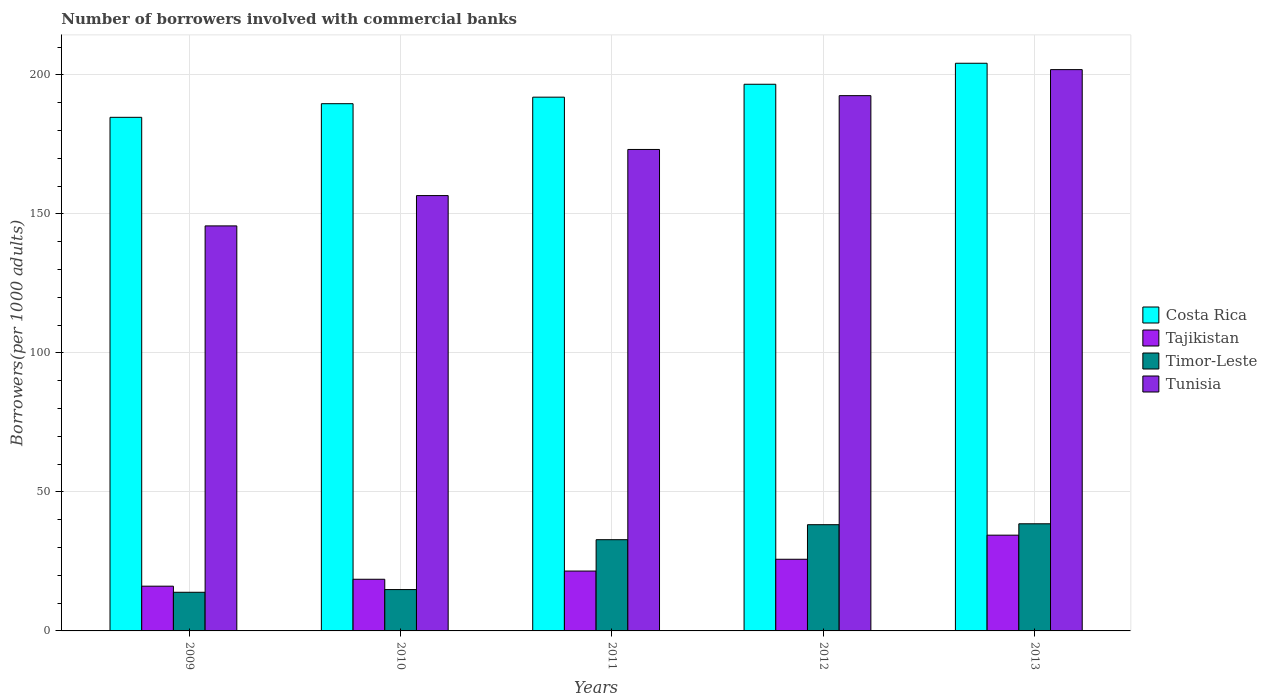How many different coloured bars are there?
Provide a succinct answer. 4. How many groups of bars are there?
Provide a succinct answer. 5. Are the number of bars per tick equal to the number of legend labels?
Give a very brief answer. Yes. How many bars are there on the 3rd tick from the left?
Give a very brief answer. 4. What is the label of the 4th group of bars from the left?
Ensure brevity in your answer.  2012. What is the number of borrowers involved with commercial banks in Tajikistan in 2010?
Ensure brevity in your answer.  18.58. Across all years, what is the maximum number of borrowers involved with commercial banks in Tajikistan?
Your response must be concise. 34.44. Across all years, what is the minimum number of borrowers involved with commercial banks in Tajikistan?
Provide a succinct answer. 16.09. In which year was the number of borrowers involved with commercial banks in Costa Rica maximum?
Offer a terse response. 2013. What is the total number of borrowers involved with commercial banks in Timor-Leste in the graph?
Keep it short and to the point. 138.33. What is the difference between the number of borrowers involved with commercial banks in Costa Rica in 2010 and that in 2011?
Keep it short and to the point. -2.35. What is the difference between the number of borrowers involved with commercial banks in Timor-Leste in 2011 and the number of borrowers involved with commercial banks in Tajikistan in 2012?
Your response must be concise. 7.04. What is the average number of borrowers involved with commercial banks in Timor-Leste per year?
Give a very brief answer. 27.67. In the year 2011, what is the difference between the number of borrowers involved with commercial banks in Costa Rica and number of borrowers involved with commercial banks in Timor-Leste?
Give a very brief answer. 159.17. What is the ratio of the number of borrowers involved with commercial banks in Costa Rica in 2010 to that in 2011?
Your answer should be compact. 0.99. What is the difference between the highest and the second highest number of borrowers involved with commercial banks in Tunisia?
Provide a short and direct response. 9.37. What is the difference between the highest and the lowest number of borrowers involved with commercial banks in Timor-Leste?
Provide a succinct answer. 24.63. In how many years, is the number of borrowers involved with commercial banks in Costa Rica greater than the average number of borrowers involved with commercial banks in Costa Rica taken over all years?
Provide a succinct answer. 2. What does the 4th bar from the left in 2012 represents?
Provide a succinct answer. Tunisia. What does the 3rd bar from the right in 2009 represents?
Ensure brevity in your answer.  Tajikistan. Is it the case that in every year, the sum of the number of borrowers involved with commercial banks in Tajikistan and number of borrowers involved with commercial banks in Costa Rica is greater than the number of borrowers involved with commercial banks in Tunisia?
Give a very brief answer. Yes. How many bars are there?
Make the answer very short. 20. How many years are there in the graph?
Provide a short and direct response. 5. Are the values on the major ticks of Y-axis written in scientific E-notation?
Your response must be concise. No. Does the graph contain any zero values?
Provide a succinct answer. No. How many legend labels are there?
Provide a succinct answer. 4. How are the legend labels stacked?
Provide a succinct answer. Vertical. What is the title of the graph?
Your answer should be very brief. Number of borrowers involved with commercial banks. Does "Tonga" appear as one of the legend labels in the graph?
Give a very brief answer. No. What is the label or title of the X-axis?
Ensure brevity in your answer.  Years. What is the label or title of the Y-axis?
Your response must be concise. Borrowers(per 1000 adults). What is the Borrowers(per 1000 adults) of Costa Rica in 2009?
Your answer should be very brief. 184.73. What is the Borrowers(per 1000 adults) in Tajikistan in 2009?
Provide a succinct answer. 16.09. What is the Borrowers(per 1000 adults) of Timor-Leste in 2009?
Provide a short and direct response. 13.9. What is the Borrowers(per 1000 adults) of Tunisia in 2009?
Offer a very short reply. 145.68. What is the Borrowers(per 1000 adults) in Costa Rica in 2010?
Make the answer very short. 189.63. What is the Borrowers(per 1000 adults) of Tajikistan in 2010?
Your answer should be compact. 18.58. What is the Borrowers(per 1000 adults) in Timor-Leste in 2010?
Give a very brief answer. 14.87. What is the Borrowers(per 1000 adults) in Tunisia in 2010?
Your response must be concise. 156.58. What is the Borrowers(per 1000 adults) in Costa Rica in 2011?
Your response must be concise. 191.98. What is the Borrowers(per 1000 adults) of Tajikistan in 2011?
Your answer should be compact. 21.53. What is the Borrowers(per 1000 adults) in Timor-Leste in 2011?
Offer a very short reply. 32.81. What is the Borrowers(per 1000 adults) in Tunisia in 2011?
Offer a very short reply. 173.17. What is the Borrowers(per 1000 adults) in Costa Rica in 2012?
Provide a short and direct response. 196.62. What is the Borrowers(per 1000 adults) in Tajikistan in 2012?
Provide a short and direct response. 25.77. What is the Borrowers(per 1000 adults) of Timor-Leste in 2012?
Offer a very short reply. 38.21. What is the Borrowers(per 1000 adults) in Tunisia in 2012?
Provide a short and direct response. 192.52. What is the Borrowers(per 1000 adults) of Costa Rica in 2013?
Ensure brevity in your answer.  204.18. What is the Borrowers(per 1000 adults) in Tajikistan in 2013?
Ensure brevity in your answer.  34.44. What is the Borrowers(per 1000 adults) of Timor-Leste in 2013?
Offer a very short reply. 38.53. What is the Borrowers(per 1000 adults) in Tunisia in 2013?
Keep it short and to the point. 201.89. Across all years, what is the maximum Borrowers(per 1000 adults) in Costa Rica?
Make the answer very short. 204.18. Across all years, what is the maximum Borrowers(per 1000 adults) in Tajikistan?
Your answer should be compact. 34.44. Across all years, what is the maximum Borrowers(per 1000 adults) of Timor-Leste?
Your answer should be compact. 38.53. Across all years, what is the maximum Borrowers(per 1000 adults) of Tunisia?
Offer a terse response. 201.89. Across all years, what is the minimum Borrowers(per 1000 adults) of Costa Rica?
Give a very brief answer. 184.73. Across all years, what is the minimum Borrowers(per 1000 adults) in Tajikistan?
Your answer should be very brief. 16.09. Across all years, what is the minimum Borrowers(per 1000 adults) in Timor-Leste?
Make the answer very short. 13.9. Across all years, what is the minimum Borrowers(per 1000 adults) in Tunisia?
Make the answer very short. 145.68. What is the total Borrowers(per 1000 adults) in Costa Rica in the graph?
Keep it short and to the point. 967.14. What is the total Borrowers(per 1000 adults) in Tajikistan in the graph?
Give a very brief answer. 116.41. What is the total Borrowers(per 1000 adults) in Timor-Leste in the graph?
Your response must be concise. 138.33. What is the total Borrowers(per 1000 adults) in Tunisia in the graph?
Make the answer very short. 869.84. What is the difference between the Borrowers(per 1000 adults) of Costa Rica in 2009 and that in 2010?
Your response must be concise. -4.9. What is the difference between the Borrowers(per 1000 adults) in Tajikistan in 2009 and that in 2010?
Provide a short and direct response. -2.49. What is the difference between the Borrowers(per 1000 adults) of Timor-Leste in 2009 and that in 2010?
Provide a succinct answer. -0.97. What is the difference between the Borrowers(per 1000 adults) of Tunisia in 2009 and that in 2010?
Ensure brevity in your answer.  -10.9. What is the difference between the Borrowers(per 1000 adults) in Costa Rica in 2009 and that in 2011?
Provide a short and direct response. -7.25. What is the difference between the Borrowers(per 1000 adults) in Tajikistan in 2009 and that in 2011?
Your answer should be compact. -5.44. What is the difference between the Borrowers(per 1000 adults) in Timor-Leste in 2009 and that in 2011?
Provide a succinct answer. -18.91. What is the difference between the Borrowers(per 1000 adults) in Tunisia in 2009 and that in 2011?
Your response must be concise. -27.5. What is the difference between the Borrowers(per 1000 adults) in Costa Rica in 2009 and that in 2012?
Keep it short and to the point. -11.9. What is the difference between the Borrowers(per 1000 adults) in Tajikistan in 2009 and that in 2012?
Give a very brief answer. -9.68. What is the difference between the Borrowers(per 1000 adults) in Timor-Leste in 2009 and that in 2012?
Give a very brief answer. -24.31. What is the difference between the Borrowers(per 1000 adults) of Tunisia in 2009 and that in 2012?
Give a very brief answer. -46.85. What is the difference between the Borrowers(per 1000 adults) in Costa Rica in 2009 and that in 2013?
Offer a terse response. -19.45. What is the difference between the Borrowers(per 1000 adults) of Tajikistan in 2009 and that in 2013?
Make the answer very short. -18.35. What is the difference between the Borrowers(per 1000 adults) of Timor-Leste in 2009 and that in 2013?
Offer a terse response. -24.63. What is the difference between the Borrowers(per 1000 adults) of Tunisia in 2009 and that in 2013?
Your answer should be very brief. -56.21. What is the difference between the Borrowers(per 1000 adults) in Costa Rica in 2010 and that in 2011?
Ensure brevity in your answer.  -2.35. What is the difference between the Borrowers(per 1000 adults) of Tajikistan in 2010 and that in 2011?
Give a very brief answer. -2.95. What is the difference between the Borrowers(per 1000 adults) in Timor-Leste in 2010 and that in 2011?
Give a very brief answer. -17.94. What is the difference between the Borrowers(per 1000 adults) of Tunisia in 2010 and that in 2011?
Offer a terse response. -16.59. What is the difference between the Borrowers(per 1000 adults) of Costa Rica in 2010 and that in 2012?
Provide a succinct answer. -6.99. What is the difference between the Borrowers(per 1000 adults) in Tajikistan in 2010 and that in 2012?
Your answer should be compact. -7.19. What is the difference between the Borrowers(per 1000 adults) in Timor-Leste in 2010 and that in 2012?
Offer a terse response. -23.34. What is the difference between the Borrowers(per 1000 adults) of Tunisia in 2010 and that in 2012?
Keep it short and to the point. -35.94. What is the difference between the Borrowers(per 1000 adults) in Costa Rica in 2010 and that in 2013?
Offer a very short reply. -14.55. What is the difference between the Borrowers(per 1000 adults) of Tajikistan in 2010 and that in 2013?
Make the answer very short. -15.86. What is the difference between the Borrowers(per 1000 adults) of Timor-Leste in 2010 and that in 2013?
Make the answer very short. -23.66. What is the difference between the Borrowers(per 1000 adults) in Tunisia in 2010 and that in 2013?
Your answer should be very brief. -45.31. What is the difference between the Borrowers(per 1000 adults) of Costa Rica in 2011 and that in 2012?
Keep it short and to the point. -4.64. What is the difference between the Borrowers(per 1000 adults) of Tajikistan in 2011 and that in 2012?
Give a very brief answer. -4.24. What is the difference between the Borrowers(per 1000 adults) of Timor-Leste in 2011 and that in 2012?
Your answer should be very brief. -5.4. What is the difference between the Borrowers(per 1000 adults) in Tunisia in 2011 and that in 2012?
Give a very brief answer. -19.35. What is the difference between the Borrowers(per 1000 adults) in Costa Rica in 2011 and that in 2013?
Provide a short and direct response. -12.19. What is the difference between the Borrowers(per 1000 adults) in Tajikistan in 2011 and that in 2013?
Keep it short and to the point. -12.91. What is the difference between the Borrowers(per 1000 adults) in Timor-Leste in 2011 and that in 2013?
Ensure brevity in your answer.  -5.72. What is the difference between the Borrowers(per 1000 adults) of Tunisia in 2011 and that in 2013?
Provide a succinct answer. -28.72. What is the difference between the Borrowers(per 1000 adults) of Costa Rica in 2012 and that in 2013?
Provide a succinct answer. -7.55. What is the difference between the Borrowers(per 1000 adults) of Tajikistan in 2012 and that in 2013?
Offer a very short reply. -8.67. What is the difference between the Borrowers(per 1000 adults) of Timor-Leste in 2012 and that in 2013?
Provide a succinct answer. -0.32. What is the difference between the Borrowers(per 1000 adults) in Tunisia in 2012 and that in 2013?
Provide a short and direct response. -9.37. What is the difference between the Borrowers(per 1000 adults) in Costa Rica in 2009 and the Borrowers(per 1000 adults) in Tajikistan in 2010?
Offer a very short reply. 166.15. What is the difference between the Borrowers(per 1000 adults) in Costa Rica in 2009 and the Borrowers(per 1000 adults) in Timor-Leste in 2010?
Provide a succinct answer. 169.86. What is the difference between the Borrowers(per 1000 adults) of Costa Rica in 2009 and the Borrowers(per 1000 adults) of Tunisia in 2010?
Offer a terse response. 28.15. What is the difference between the Borrowers(per 1000 adults) in Tajikistan in 2009 and the Borrowers(per 1000 adults) in Timor-Leste in 2010?
Offer a very short reply. 1.22. What is the difference between the Borrowers(per 1000 adults) in Tajikistan in 2009 and the Borrowers(per 1000 adults) in Tunisia in 2010?
Keep it short and to the point. -140.49. What is the difference between the Borrowers(per 1000 adults) of Timor-Leste in 2009 and the Borrowers(per 1000 adults) of Tunisia in 2010?
Ensure brevity in your answer.  -142.68. What is the difference between the Borrowers(per 1000 adults) in Costa Rica in 2009 and the Borrowers(per 1000 adults) in Tajikistan in 2011?
Offer a very short reply. 163.2. What is the difference between the Borrowers(per 1000 adults) in Costa Rica in 2009 and the Borrowers(per 1000 adults) in Timor-Leste in 2011?
Give a very brief answer. 151.92. What is the difference between the Borrowers(per 1000 adults) of Costa Rica in 2009 and the Borrowers(per 1000 adults) of Tunisia in 2011?
Provide a succinct answer. 11.56. What is the difference between the Borrowers(per 1000 adults) in Tajikistan in 2009 and the Borrowers(per 1000 adults) in Timor-Leste in 2011?
Your answer should be very brief. -16.72. What is the difference between the Borrowers(per 1000 adults) in Tajikistan in 2009 and the Borrowers(per 1000 adults) in Tunisia in 2011?
Offer a very short reply. -157.08. What is the difference between the Borrowers(per 1000 adults) of Timor-Leste in 2009 and the Borrowers(per 1000 adults) of Tunisia in 2011?
Your response must be concise. -159.27. What is the difference between the Borrowers(per 1000 adults) of Costa Rica in 2009 and the Borrowers(per 1000 adults) of Tajikistan in 2012?
Your answer should be very brief. 158.95. What is the difference between the Borrowers(per 1000 adults) of Costa Rica in 2009 and the Borrowers(per 1000 adults) of Timor-Leste in 2012?
Your answer should be compact. 146.52. What is the difference between the Borrowers(per 1000 adults) in Costa Rica in 2009 and the Borrowers(per 1000 adults) in Tunisia in 2012?
Provide a short and direct response. -7.8. What is the difference between the Borrowers(per 1000 adults) in Tajikistan in 2009 and the Borrowers(per 1000 adults) in Timor-Leste in 2012?
Offer a very short reply. -22.12. What is the difference between the Borrowers(per 1000 adults) in Tajikistan in 2009 and the Borrowers(per 1000 adults) in Tunisia in 2012?
Ensure brevity in your answer.  -176.43. What is the difference between the Borrowers(per 1000 adults) in Timor-Leste in 2009 and the Borrowers(per 1000 adults) in Tunisia in 2012?
Your response must be concise. -178.62. What is the difference between the Borrowers(per 1000 adults) in Costa Rica in 2009 and the Borrowers(per 1000 adults) in Tajikistan in 2013?
Make the answer very short. 150.29. What is the difference between the Borrowers(per 1000 adults) in Costa Rica in 2009 and the Borrowers(per 1000 adults) in Timor-Leste in 2013?
Provide a short and direct response. 146.19. What is the difference between the Borrowers(per 1000 adults) in Costa Rica in 2009 and the Borrowers(per 1000 adults) in Tunisia in 2013?
Give a very brief answer. -17.16. What is the difference between the Borrowers(per 1000 adults) of Tajikistan in 2009 and the Borrowers(per 1000 adults) of Timor-Leste in 2013?
Your response must be concise. -22.44. What is the difference between the Borrowers(per 1000 adults) in Tajikistan in 2009 and the Borrowers(per 1000 adults) in Tunisia in 2013?
Your answer should be compact. -185.8. What is the difference between the Borrowers(per 1000 adults) of Timor-Leste in 2009 and the Borrowers(per 1000 adults) of Tunisia in 2013?
Your answer should be compact. -187.99. What is the difference between the Borrowers(per 1000 adults) of Costa Rica in 2010 and the Borrowers(per 1000 adults) of Tajikistan in 2011?
Make the answer very short. 168.1. What is the difference between the Borrowers(per 1000 adults) in Costa Rica in 2010 and the Borrowers(per 1000 adults) in Timor-Leste in 2011?
Offer a very short reply. 156.82. What is the difference between the Borrowers(per 1000 adults) of Costa Rica in 2010 and the Borrowers(per 1000 adults) of Tunisia in 2011?
Your answer should be very brief. 16.46. What is the difference between the Borrowers(per 1000 adults) in Tajikistan in 2010 and the Borrowers(per 1000 adults) in Timor-Leste in 2011?
Offer a terse response. -14.23. What is the difference between the Borrowers(per 1000 adults) of Tajikistan in 2010 and the Borrowers(per 1000 adults) of Tunisia in 2011?
Offer a terse response. -154.59. What is the difference between the Borrowers(per 1000 adults) of Timor-Leste in 2010 and the Borrowers(per 1000 adults) of Tunisia in 2011?
Offer a very short reply. -158.3. What is the difference between the Borrowers(per 1000 adults) of Costa Rica in 2010 and the Borrowers(per 1000 adults) of Tajikistan in 2012?
Offer a very short reply. 163.85. What is the difference between the Borrowers(per 1000 adults) of Costa Rica in 2010 and the Borrowers(per 1000 adults) of Timor-Leste in 2012?
Offer a terse response. 151.42. What is the difference between the Borrowers(per 1000 adults) in Costa Rica in 2010 and the Borrowers(per 1000 adults) in Tunisia in 2012?
Give a very brief answer. -2.89. What is the difference between the Borrowers(per 1000 adults) of Tajikistan in 2010 and the Borrowers(per 1000 adults) of Timor-Leste in 2012?
Your answer should be very brief. -19.63. What is the difference between the Borrowers(per 1000 adults) of Tajikistan in 2010 and the Borrowers(per 1000 adults) of Tunisia in 2012?
Your answer should be very brief. -173.94. What is the difference between the Borrowers(per 1000 adults) in Timor-Leste in 2010 and the Borrowers(per 1000 adults) in Tunisia in 2012?
Offer a terse response. -177.65. What is the difference between the Borrowers(per 1000 adults) of Costa Rica in 2010 and the Borrowers(per 1000 adults) of Tajikistan in 2013?
Make the answer very short. 155.19. What is the difference between the Borrowers(per 1000 adults) of Costa Rica in 2010 and the Borrowers(per 1000 adults) of Timor-Leste in 2013?
Provide a succinct answer. 151.09. What is the difference between the Borrowers(per 1000 adults) in Costa Rica in 2010 and the Borrowers(per 1000 adults) in Tunisia in 2013?
Your response must be concise. -12.26. What is the difference between the Borrowers(per 1000 adults) of Tajikistan in 2010 and the Borrowers(per 1000 adults) of Timor-Leste in 2013?
Give a very brief answer. -19.95. What is the difference between the Borrowers(per 1000 adults) of Tajikistan in 2010 and the Borrowers(per 1000 adults) of Tunisia in 2013?
Offer a terse response. -183.31. What is the difference between the Borrowers(per 1000 adults) in Timor-Leste in 2010 and the Borrowers(per 1000 adults) in Tunisia in 2013?
Provide a succinct answer. -187.02. What is the difference between the Borrowers(per 1000 adults) of Costa Rica in 2011 and the Borrowers(per 1000 adults) of Tajikistan in 2012?
Keep it short and to the point. 166.21. What is the difference between the Borrowers(per 1000 adults) of Costa Rica in 2011 and the Borrowers(per 1000 adults) of Timor-Leste in 2012?
Your answer should be very brief. 153.77. What is the difference between the Borrowers(per 1000 adults) of Costa Rica in 2011 and the Borrowers(per 1000 adults) of Tunisia in 2012?
Your response must be concise. -0.54. What is the difference between the Borrowers(per 1000 adults) in Tajikistan in 2011 and the Borrowers(per 1000 adults) in Timor-Leste in 2012?
Provide a succinct answer. -16.68. What is the difference between the Borrowers(per 1000 adults) in Tajikistan in 2011 and the Borrowers(per 1000 adults) in Tunisia in 2012?
Make the answer very short. -170.99. What is the difference between the Borrowers(per 1000 adults) of Timor-Leste in 2011 and the Borrowers(per 1000 adults) of Tunisia in 2012?
Your answer should be very brief. -159.71. What is the difference between the Borrowers(per 1000 adults) in Costa Rica in 2011 and the Borrowers(per 1000 adults) in Tajikistan in 2013?
Your answer should be very brief. 157.54. What is the difference between the Borrowers(per 1000 adults) of Costa Rica in 2011 and the Borrowers(per 1000 adults) of Timor-Leste in 2013?
Offer a very short reply. 153.45. What is the difference between the Borrowers(per 1000 adults) of Costa Rica in 2011 and the Borrowers(per 1000 adults) of Tunisia in 2013?
Provide a short and direct response. -9.91. What is the difference between the Borrowers(per 1000 adults) of Tajikistan in 2011 and the Borrowers(per 1000 adults) of Timor-Leste in 2013?
Your response must be concise. -17. What is the difference between the Borrowers(per 1000 adults) in Tajikistan in 2011 and the Borrowers(per 1000 adults) in Tunisia in 2013?
Your response must be concise. -180.36. What is the difference between the Borrowers(per 1000 adults) in Timor-Leste in 2011 and the Borrowers(per 1000 adults) in Tunisia in 2013?
Your response must be concise. -169.08. What is the difference between the Borrowers(per 1000 adults) in Costa Rica in 2012 and the Borrowers(per 1000 adults) in Tajikistan in 2013?
Make the answer very short. 162.18. What is the difference between the Borrowers(per 1000 adults) of Costa Rica in 2012 and the Borrowers(per 1000 adults) of Timor-Leste in 2013?
Keep it short and to the point. 158.09. What is the difference between the Borrowers(per 1000 adults) of Costa Rica in 2012 and the Borrowers(per 1000 adults) of Tunisia in 2013?
Your response must be concise. -5.27. What is the difference between the Borrowers(per 1000 adults) of Tajikistan in 2012 and the Borrowers(per 1000 adults) of Timor-Leste in 2013?
Provide a succinct answer. -12.76. What is the difference between the Borrowers(per 1000 adults) of Tajikistan in 2012 and the Borrowers(per 1000 adults) of Tunisia in 2013?
Provide a short and direct response. -176.12. What is the difference between the Borrowers(per 1000 adults) of Timor-Leste in 2012 and the Borrowers(per 1000 adults) of Tunisia in 2013?
Give a very brief answer. -163.68. What is the average Borrowers(per 1000 adults) in Costa Rica per year?
Ensure brevity in your answer.  193.43. What is the average Borrowers(per 1000 adults) in Tajikistan per year?
Your answer should be very brief. 23.28. What is the average Borrowers(per 1000 adults) of Timor-Leste per year?
Offer a terse response. 27.67. What is the average Borrowers(per 1000 adults) of Tunisia per year?
Keep it short and to the point. 173.97. In the year 2009, what is the difference between the Borrowers(per 1000 adults) in Costa Rica and Borrowers(per 1000 adults) in Tajikistan?
Your response must be concise. 168.64. In the year 2009, what is the difference between the Borrowers(per 1000 adults) of Costa Rica and Borrowers(per 1000 adults) of Timor-Leste?
Make the answer very short. 170.82. In the year 2009, what is the difference between the Borrowers(per 1000 adults) in Costa Rica and Borrowers(per 1000 adults) in Tunisia?
Your answer should be very brief. 39.05. In the year 2009, what is the difference between the Borrowers(per 1000 adults) in Tajikistan and Borrowers(per 1000 adults) in Timor-Leste?
Offer a terse response. 2.19. In the year 2009, what is the difference between the Borrowers(per 1000 adults) of Tajikistan and Borrowers(per 1000 adults) of Tunisia?
Provide a succinct answer. -129.59. In the year 2009, what is the difference between the Borrowers(per 1000 adults) in Timor-Leste and Borrowers(per 1000 adults) in Tunisia?
Provide a succinct answer. -131.77. In the year 2010, what is the difference between the Borrowers(per 1000 adults) of Costa Rica and Borrowers(per 1000 adults) of Tajikistan?
Your answer should be very brief. 171.05. In the year 2010, what is the difference between the Borrowers(per 1000 adults) in Costa Rica and Borrowers(per 1000 adults) in Timor-Leste?
Your answer should be very brief. 174.76. In the year 2010, what is the difference between the Borrowers(per 1000 adults) of Costa Rica and Borrowers(per 1000 adults) of Tunisia?
Keep it short and to the point. 33.05. In the year 2010, what is the difference between the Borrowers(per 1000 adults) in Tajikistan and Borrowers(per 1000 adults) in Timor-Leste?
Provide a succinct answer. 3.71. In the year 2010, what is the difference between the Borrowers(per 1000 adults) of Tajikistan and Borrowers(per 1000 adults) of Tunisia?
Give a very brief answer. -138. In the year 2010, what is the difference between the Borrowers(per 1000 adults) in Timor-Leste and Borrowers(per 1000 adults) in Tunisia?
Your answer should be compact. -141.71. In the year 2011, what is the difference between the Borrowers(per 1000 adults) of Costa Rica and Borrowers(per 1000 adults) of Tajikistan?
Provide a succinct answer. 170.45. In the year 2011, what is the difference between the Borrowers(per 1000 adults) in Costa Rica and Borrowers(per 1000 adults) in Timor-Leste?
Keep it short and to the point. 159.17. In the year 2011, what is the difference between the Borrowers(per 1000 adults) of Costa Rica and Borrowers(per 1000 adults) of Tunisia?
Offer a terse response. 18.81. In the year 2011, what is the difference between the Borrowers(per 1000 adults) of Tajikistan and Borrowers(per 1000 adults) of Timor-Leste?
Your response must be concise. -11.28. In the year 2011, what is the difference between the Borrowers(per 1000 adults) in Tajikistan and Borrowers(per 1000 adults) in Tunisia?
Keep it short and to the point. -151.64. In the year 2011, what is the difference between the Borrowers(per 1000 adults) in Timor-Leste and Borrowers(per 1000 adults) in Tunisia?
Make the answer very short. -140.36. In the year 2012, what is the difference between the Borrowers(per 1000 adults) of Costa Rica and Borrowers(per 1000 adults) of Tajikistan?
Your answer should be compact. 170.85. In the year 2012, what is the difference between the Borrowers(per 1000 adults) in Costa Rica and Borrowers(per 1000 adults) in Timor-Leste?
Your response must be concise. 158.41. In the year 2012, what is the difference between the Borrowers(per 1000 adults) of Costa Rica and Borrowers(per 1000 adults) of Tunisia?
Your response must be concise. 4.1. In the year 2012, what is the difference between the Borrowers(per 1000 adults) in Tajikistan and Borrowers(per 1000 adults) in Timor-Leste?
Keep it short and to the point. -12.44. In the year 2012, what is the difference between the Borrowers(per 1000 adults) of Tajikistan and Borrowers(per 1000 adults) of Tunisia?
Keep it short and to the point. -166.75. In the year 2012, what is the difference between the Borrowers(per 1000 adults) of Timor-Leste and Borrowers(per 1000 adults) of Tunisia?
Ensure brevity in your answer.  -154.31. In the year 2013, what is the difference between the Borrowers(per 1000 adults) in Costa Rica and Borrowers(per 1000 adults) in Tajikistan?
Offer a terse response. 169.73. In the year 2013, what is the difference between the Borrowers(per 1000 adults) of Costa Rica and Borrowers(per 1000 adults) of Timor-Leste?
Your response must be concise. 165.64. In the year 2013, what is the difference between the Borrowers(per 1000 adults) of Costa Rica and Borrowers(per 1000 adults) of Tunisia?
Make the answer very short. 2.29. In the year 2013, what is the difference between the Borrowers(per 1000 adults) of Tajikistan and Borrowers(per 1000 adults) of Timor-Leste?
Your answer should be very brief. -4.09. In the year 2013, what is the difference between the Borrowers(per 1000 adults) in Tajikistan and Borrowers(per 1000 adults) in Tunisia?
Your answer should be compact. -167.45. In the year 2013, what is the difference between the Borrowers(per 1000 adults) in Timor-Leste and Borrowers(per 1000 adults) in Tunisia?
Give a very brief answer. -163.36. What is the ratio of the Borrowers(per 1000 adults) in Costa Rica in 2009 to that in 2010?
Make the answer very short. 0.97. What is the ratio of the Borrowers(per 1000 adults) of Tajikistan in 2009 to that in 2010?
Your answer should be compact. 0.87. What is the ratio of the Borrowers(per 1000 adults) in Timor-Leste in 2009 to that in 2010?
Provide a short and direct response. 0.94. What is the ratio of the Borrowers(per 1000 adults) of Tunisia in 2009 to that in 2010?
Your response must be concise. 0.93. What is the ratio of the Borrowers(per 1000 adults) of Costa Rica in 2009 to that in 2011?
Provide a short and direct response. 0.96. What is the ratio of the Borrowers(per 1000 adults) in Tajikistan in 2009 to that in 2011?
Keep it short and to the point. 0.75. What is the ratio of the Borrowers(per 1000 adults) of Timor-Leste in 2009 to that in 2011?
Offer a very short reply. 0.42. What is the ratio of the Borrowers(per 1000 adults) in Tunisia in 2009 to that in 2011?
Offer a terse response. 0.84. What is the ratio of the Borrowers(per 1000 adults) of Costa Rica in 2009 to that in 2012?
Offer a very short reply. 0.94. What is the ratio of the Borrowers(per 1000 adults) of Tajikistan in 2009 to that in 2012?
Offer a very short reply. 0.62. What is the ratio of the Borrowers(per 1000 adults) of Timor-Leste in 2009 to that in 2012?
Keep it short and to the point. 0.36. What is the ratio of the Borrowers(per 1000 adults) in Tunisia in 2009 to that in 2012?
Your answer should be compact. 0.76. What is the ratio of the Borrowers(per 1000 adults) in Costa Rica in 2009 to that in 2013?
Ensure brevity in your answer.  0.9. What is the ratio of the Borrowers(per 1000 adults) in Tajikistan in 2009 to that in 2013?
Your response must be concise. 0.47. What is the ratio of the Borrowers(per 1000 adults) in Timor-Leste in 2009 to that in 2013?
Make the answer very short. 0.36. What is the ratio of the Borrowers(per 1000 adults) in Tunisia in 2009 to that in 2013?
Make the answer very short. 0.72. What is the ratio of the Borrowers(per 1000 adults) in Tajikistan in 2010 to that in 2011?
Ensure brevity in your answer.  0.86. What is the ratio of the Borrowers(per 1000 adults) in Timor-Leste in 2010 to that in 2011?
Provide a short and direct response. 0.45. What is the ratio of the Borrowers(per 1000 adults) in Tunisia in 2010 to that in 2011?
Offer a very short reply. 0.9. What is the ratio of the Borrowers(per 1000 adults) of Costa Rica in 2010 to that in 2012?
Give a very brief answer. 0.96. What is the ratio of the Borrowers(per 1000 adults) of Tajikistan in 2010 to that in 2012?
Your response must be concise. 0.72. What is the ratio of the Borrowers(per 1000 adults) of Timor-Leste in 2010 to that in 2012?
Provide a short and direct response. 0.39. What is the ratio of the Borrowers(per 1000 adults) of Tunisia in 2010 to that in 2012?
Give a very brief answer. 0.81. What is the ratio of the Borrowers(per 1000 adults) of Costa Rica in 2010 to that in 2013?
Your response must be concise. 0.93. What is the ratio of the Borrowers(per 1000 adults) in Tajikistan in 2010 to that in 2013?
Offer a very short reply. 0.54. What is the ratio of the Borrowers(per 1000 adults) of Timor-Leste in 2010 to that in 2013?
Keep it short and to the point. 0.39. What is the ratio of the Borrowers(per 1000 adults) of Tunisia in 2010 to that in 2013?
Ensure brevity in your answer.  0.78. What is the ratio of the Borrowers(per 1000 adults) of Costa Rica in 2011 to that in 2012?
Make the answer very short. 0.98. What is the ratio of the Borrowers(per 1000 adults) of Tajikistan in 2011 to that in 2012?
Ensure brevity in your answer.  0.84. What is the ratio of the Borrowers(per 1000 adults) of Timor-Leste in 2011 to that in 2012?
Offer a terse response. 0.86. What is the ratio of the Borrowers(per 1000 adults) in Tunisia in 2011 to that in 2012?
Ensure brevity in your answer.  0.9. What is the ratio of the Borrowers(per 1000 adults) in Costa Rica in 2011 to that in 2013?
Give a very brief answer. 0.94. What is the ratio of the Borrowers(per 1000 adults) in Tajikistan in 2011 to that in 2013?
Ensure brevity in your answer.  0.63. What is the ratio of the Borrowers(per 1000 adults) in Timor-Leste in 2011 to that in 2013?
Provide a succinct answer. 0.85. What is the ratio of the Borrowers(per 1000 adults) in Tunisia in 2011 to that in 2013?
Provide a succinct answer. 0.86. What is the ratio of the Borrowers(per 1000 adults) in Tajikistan in 2012 to that in 2013?
Your answer should be very brief. 0.75. What is the ratio of the Borrowers(per 1000 adults) of Tunisia in 2012 to that in 2013?
Your answer should be very brief. 0.95. What is the difference between the highest and the second highest Borrowers(per 1000 adults) in Costa Rica?
Provide a succinct answer. 7.55. What is the difference between the highest and the second highest Borrowers(per 1000 adults) in Tajikistan?
Ensure brevity in your answer.  8.67. What is the difference between the highest and the second highest Borrowers(per 1000 adults) of Timor-Leste?
Ensure brevity in your answer.  0.32. What is the difference between the highest and the second highest Borrowers(per 1000 adults) of Tunisia?
Provide a short and direct response. 9.37. What is the difference between the highest and the lowest Borrowers(per 1000 adults) of Costa Rica?
Offer a very short reply. 19.45. What is the difference between the highest and the lowest Borrowers(per 1000 adults) of Tajikistan?
Offer a terse response. 18.35. What is the difference between the highest and the lowest Borrowers(per 1000 adults) of Timor-Leste?
Keep it short and to the point. 24.63. What is the difference between the highest and the lowest Borrowers(per 1000 adults) in Tunisia?
Provide a short and direct response. 56.21. 